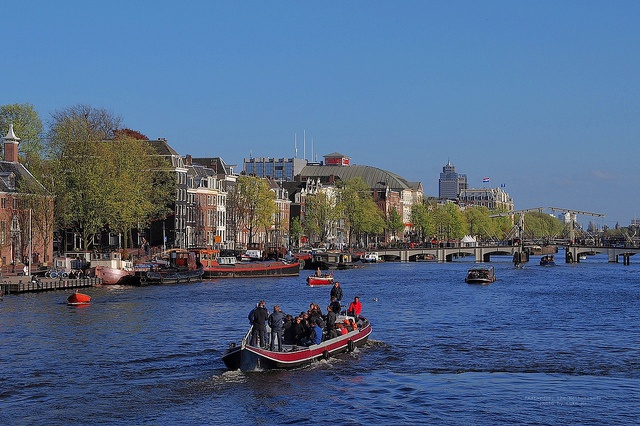Describe the objects in this image and their specific colors. I can see boat in gray, black, brown, and darkgray tones, boat in gray, black, brown, and maroon tones, boat in gray, black, and maroon tones, boat in gray and black tones, and people in gray, black, navy, and darkblue tones in this image. 